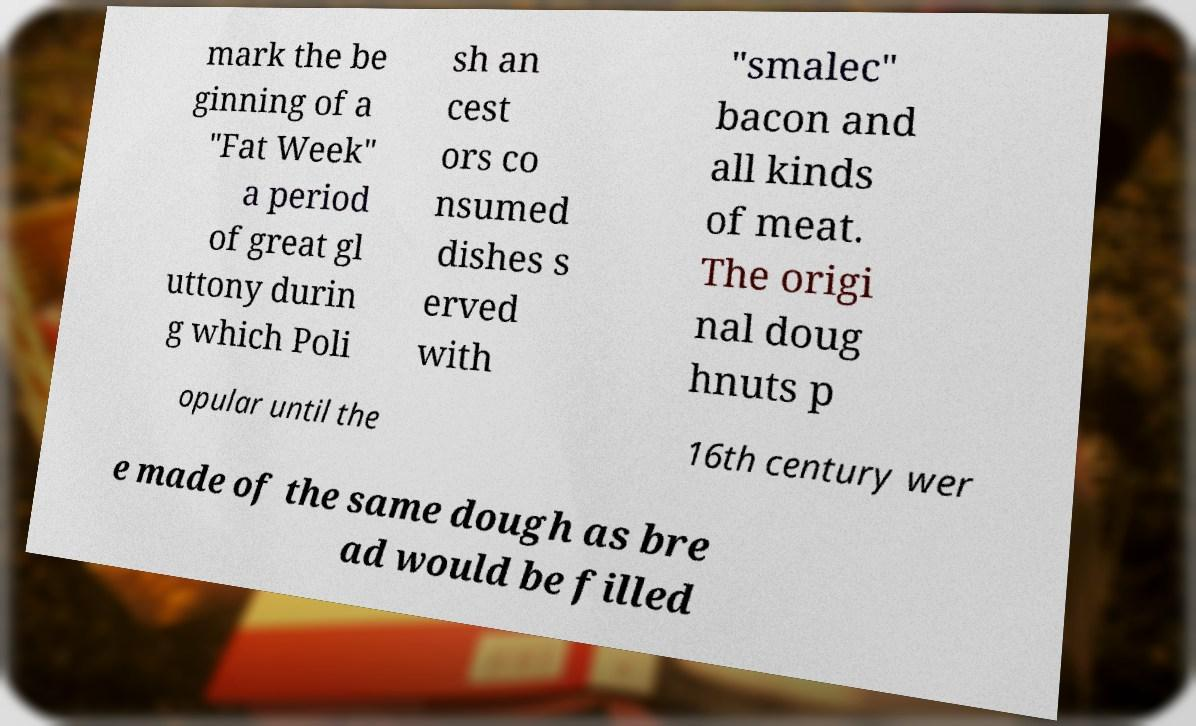What messages or text are displayed in this image? I need them in a readable, typed format. mark the be ginning of a "Fat Week" a period of great gl uttony durin g which Poli sh an cest ors co nsumed dishes s erved with "smalec" bacon and all kinds of meat. The origi nal doug hnuts p opular until the 16th century wer e made of the same dough as bre ad would be filled 